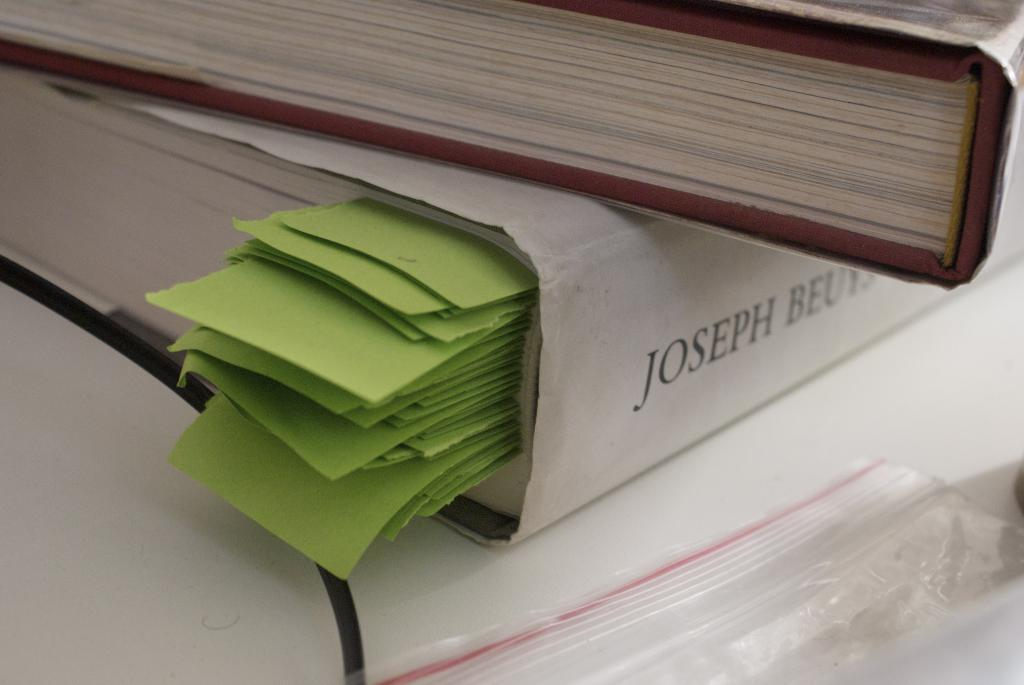<image>
Render a clear and concise summary of the photo. A book with green pieces of paper inserted into it.  The name Joseph is visible. 